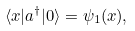<formula> <loc_0><loc_0><loc_500><loc_500>\langle x | a ^ { \dagger } | 0 \rangle = \psi _ { 1 } ( x ) ,</formula> 